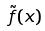Convert formula to latex. <formula><loc_0><loc_0><loc_500><loc_500>\tilde { f } ( x )</formula> 